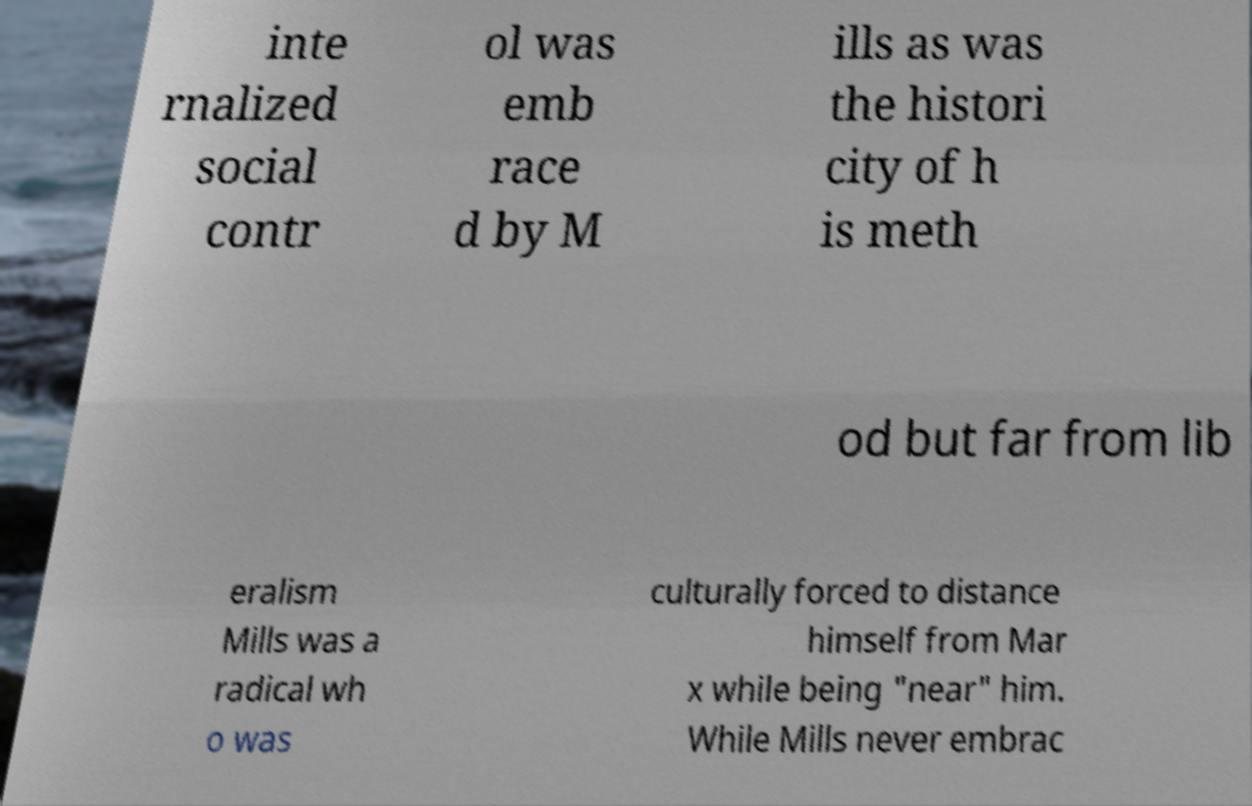For documentation purposes, I need the text within this image transcribed. Could you provide that? inte rnalized social contr ol was emb race d by M ills as was the histori city of h is meth od but far from lib eralism Mills was a radical wh o was culturally forced to distance himself from Mar x while being "near" him. While Mills never embrac 